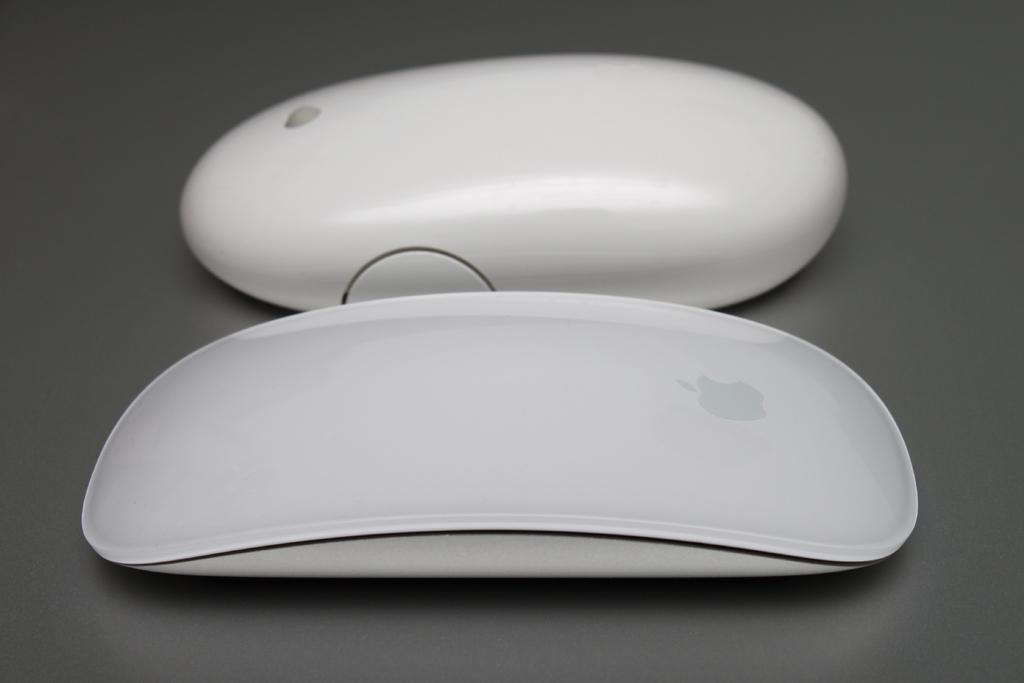What objects are present in the image? There are two devices in the image. Where are the devices located? The devices are on the floor. How many chairs are visible in the image? There are no chairs present in the image; it only features two devices on the floor. Is there a mask floating in space in the image? There is no mask or space present in the image; it only features two devices on the floor. 